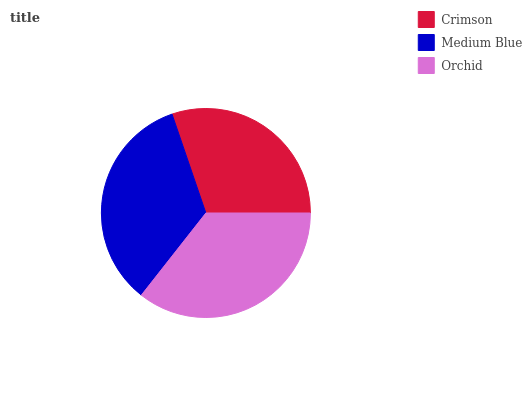Is Crimson the minimum?
Answer yes or no. Yes. Is Orchid the maximum?
Answer yes or no. Yes. Is Medium Blue the minimum?
Answer yes or no. No. Is Medium Blue the maximum?
Answer yes or no. No. Is Medium Blue greater than Crimson?
Answer yes or no. Yes. Is Crimson less than Medium Blue?
Answer yes or no. Yes. Is Crimson greater than Medium Blue?
Answer yes or no. No. Is Medium Blue less than Crimson?
Answer yes or no. No. Is Medium Blue the high median?
Answer yes or no. Yes. Is Medium Blue the low median?
Answer yes or no. Yes. Is Crimson the high median?
Answer yes or no. No. Is Crimson the low median?
Answer yes or no. No. 